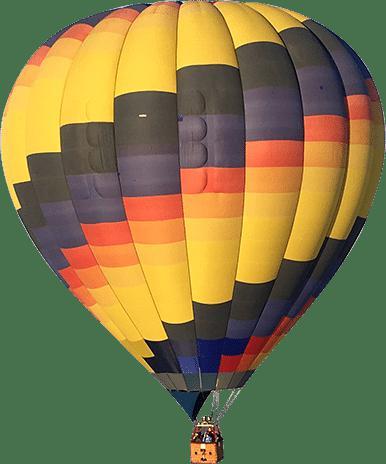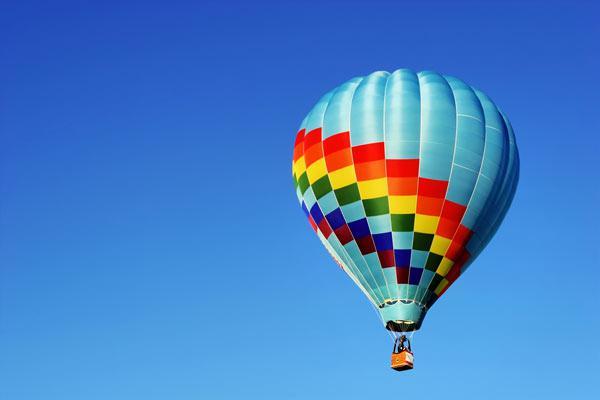The first image is the image on the left, the second image is the image on the right. Examine the images to the left and right. Is the description "Right image features exactly one balloon, which is decorated with checkerboard pattern." accurate? Answer yes or no. Yes. 